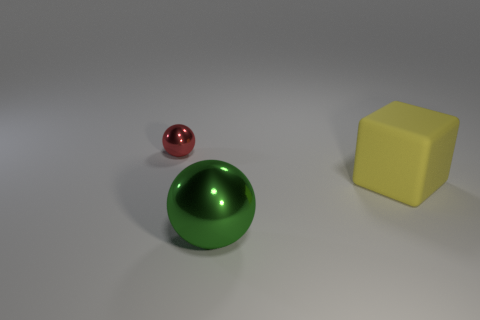What color is the ball on the right side of the small object?
Your answer should be very brief. Green. There is a shiny thing in front of the red object; is its size the same as the tiny red metal sphere?
Offer a terse response. No. What is the size of the other thing that is the same shape as the big green thing?
Ensure brevity in your answer.  Small. Are there any other things that have the same size as the green thing?
Your answer should be compact. Yes. Is the shape of the large matte thing the same as the big green thing?
Offer a very short reply. No. Is the number of large metallic spheres that are behind the big green thing less than the number of green objects right of the big yellow thing?
Offer a very short reply. No. There is a large green sphere; how many big green metallic objects are to the right of it?
Make the answer very short. 0. There is a shiny object in front of the large matte cube; does it have the same shape as the object that is behind the large matte thing?
Provide a succinct answer. Yes. There is a sphere in front of the metallic sphere that is behind the ball in front of the large yellow object; what is its material?
Give a very brief answer. Metal. There is a big thing that is behind the metal ball right of the tiny red metal object; what is it made of?
Your answer should be compact. Rubber. 